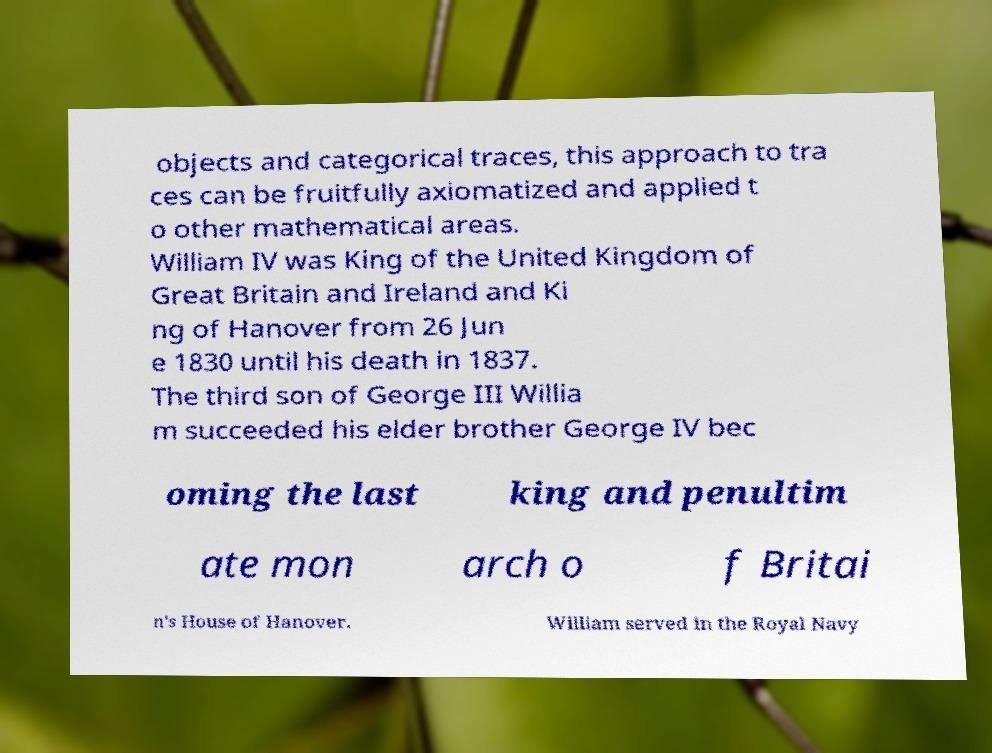Can you accurately transcribe the text from the provided image for me? objects and categorical traces, this approach to tra ces can be fruitfully axiomatized and applied t o other mathematical areas. William IV was King of the United Kingdom of Great Britain and Ireland and Ki ng of Hanover from 26 Jun e 1830 until his death in 1837. The third son of George III Willia m succeeded his elder brother George IV bec oming the last king and penultim ate mon arch o f Britai n's House of Hanover. William served in the Royal Navy 